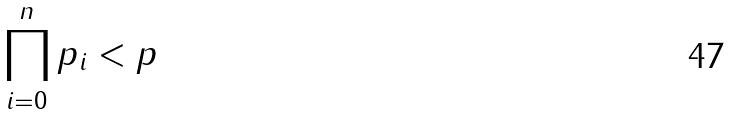Convert formula to latex. <formula><loc_0><loc_0><loc_500><loc_500>\prod _ { i = 0 } ^ { n } p _ { i } < p</formula> 